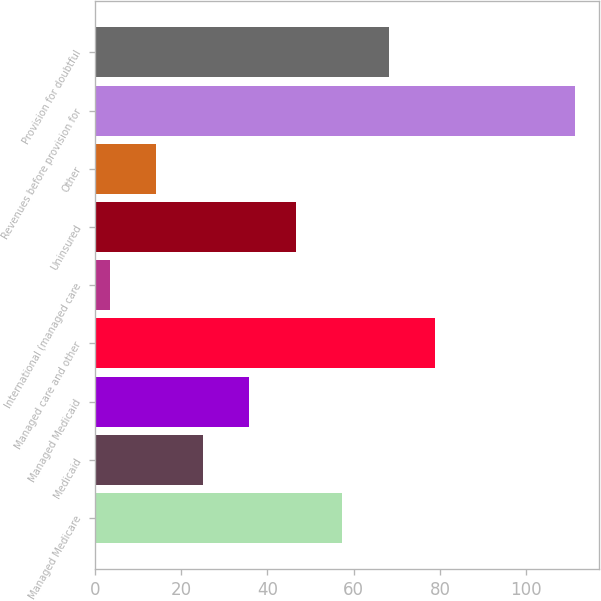Convert chart to OTSL. <chart><loc_0><loc_0><loc_500><loc_500><bar_chart><fcel>Managed Medicare<fcel>Medicaid<fcel>Managed Medicaid<fcel>Managed care and other<fcel>International (managed care<fcel>Uninsured<fcel>Other<fcel>Revenues before provision for<fcel>Provision for doubtful<nl><fcel>57.35<fcel>24.98<fcel>35.77<fcel>78.93<fcel>3.4<fcel>46.56<fcel>14.19<fcel>111.3<fcel>68.14<nl></chart> 